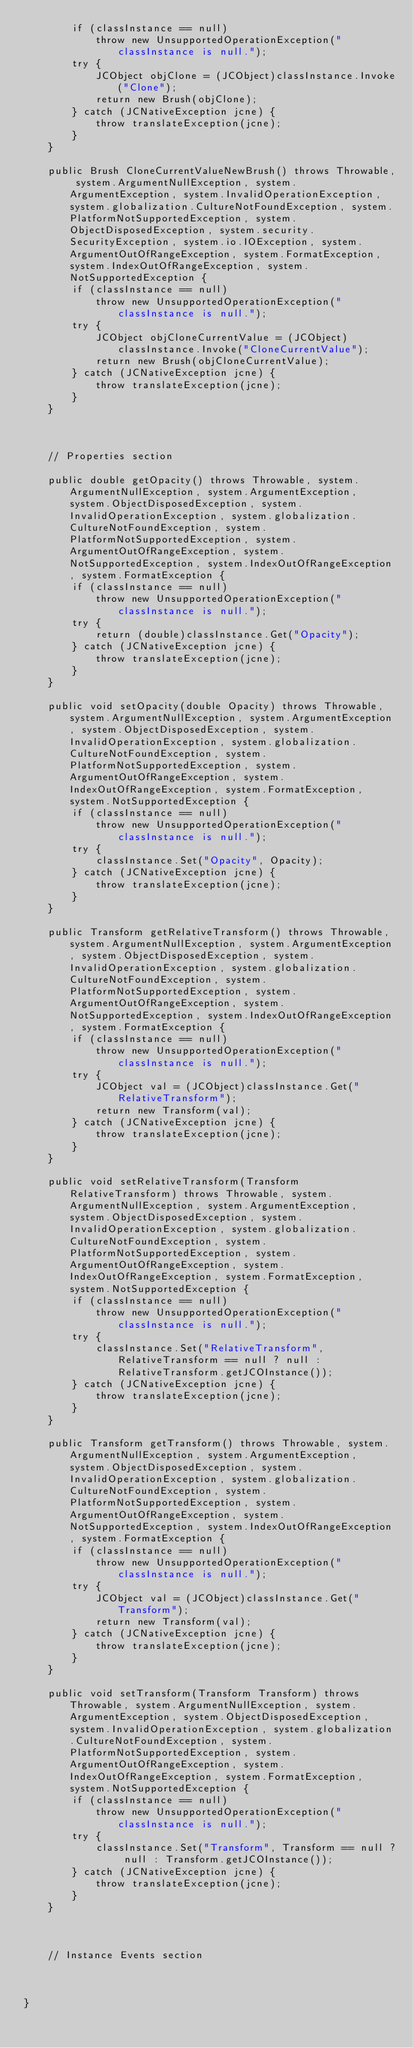<code> <loc_0><loc_0><loc_500><loc_500><_Java_>        if (classInstance == null)
            throw new UnsupportedOperationException("classInstance is null.");
        try {
            JCObject objClone = (JCObject)classInstance.Invoke("Clone");
            return new Brush(objClone);
        } catch (JCNativeException jcne) {
            throw translateException(jcne);
        }
    }

    public Brush CloneCurrentValueNewBrush() throws Throwable, system.ArgumentNullException, system.ArgumentException, system.InvalidOperationException, system.globalization.CultureNotFoundException, system.PlatformNotSupportedException, system.ObjectDisposedException, system.security.SecurityException, system.io.IOException, system.ArgumentOutOfRangeException, system.FormatException, system.IndexOutOfRangeException, system.NotSupportedException {
        if (classInstance == null)
            throw new UnsupportedOperationException("classInstance is null.");
        try {
            JCObject objCloneCurrentValue = (JCObject)classInstance.Invoke("CloneCurrentValue");
            return new Brush(objCloneCurrentValue);
        } catch (JCNativeException jcne) {
            throw translateException(jcne);
        }
    }


    
    // Properties section
    
    public double getOpacity() throws Throwable, system.ArgumentNullException, system.ArgumentException, system.ObjectDisposedException, system.InvalidOperationException, system.globalization.CultureNotFoundException, system.PlatformNotSupportedException, system.ArgumentOutOfRangeException, system.NotSupportedException, system.IndexOutOfRangeException, system.FormatException {
        if (classInstance == null)
            throw new UnsupportedOperationException("classInstance is null.");
        try {
            return (double)classInstance.Get("Opacity");
        } catch (JCNativeException jcne) {
            throw translateException(jcne);
        }
    }

    public void setOpacity(double Opacity) throws Throwable, system.ArgumentNullException, system.ArgumentException, system.ObjectDisposedException, system.InvalidOperationException, system.globalization.CultureNotFoundException, system.PlatformNotSupportedException, system.ArgumentOutOfRangeException, system.IndexOutOfRangeException, system.FormatException, system.NotSupportedException {
        if (classInstance == null)
            throw new UnsupportedOperationException("classInstance is null.");
        try {
            classInstance.Set("Opacity", Opacity);
        } catch (JCNativeException jcne) {
            throw translateException(jcne);
        }
    }

    public Transform getRelativeTransform() throws Throwable, system.ArgumentNullException, system.ArgumentException, system.ObjectDisposedException, system.InvalidOperationException, system.globalization.CultureNotFoundException, system.PlatformNotSupportedException, system.ArgumentOutOfRangeException, system.NotSupportedException, system.IndexOutOfRangeException, system.FormatException {
        if (classInstance == null)
            throw new UnsupportedOperationException("classInstance is null.");
        try {
            JCObject val = (JCObject)classInstance.Get("RelativeTransform");
            return new Transform(val);
        } catch (JCNativeException jcne) {
            throw translateException(jcne);
        }
    }

    public void setRelativeTransform(Transform RelativeTransform) throws Throwable, system.ArgumentNullException, system.ArgumentException, system.ObjectDisposedException, system.InvalidOperationException, system.globalization.CultureNotFoundException, system.PlatformNotSupportedException, system.ArgumentOutOfRangeException, system.IndexOutOfRangeException, system.FormatException, system.NotSupportedException {
        if (classInstance == null)
            throw new UnsupportedOperationException("classInstance is null.");
        try {
            classInstance.Set("RelativeTransform", RelativeTransform == null ? null : RelativeTransform.getJCOInstance());
        } catch (JCNativeException jcne) {
            throw translateException(jcne);
        }
    }

    public Transform getTransform() throws Throwable, system.ArgumentNullException, system.ArgumentException, system.ObjectDisposedException, system.InvalidOperationException, system.globalization.CultureNotFoundException, system.PlatformNotSupportedException, system.ArgumentOutOfRangeException, system.NotSupportedException, system.IndexOutOfRangeException, system.FormatException {
        if (classInstance == null)
            throw new UnsupportedOperationException("classInstance is null.");
        try {
            JCObject val = (JCObject)classInstance.Get("Transform");
            return new Transform(val);
        } catch (JCNativeException jcne) {
            throw translateException(jcne);
        }
    }

    public void setTransform(Transform Transform) throws Throwable, system.ArgumentNullException, system.ArgumentException, system.ObjectDisposedException, system.InvalidOperationException, system.globalization.CultureNotFoundException, system.PlatformNotSupportedException, system.ArgumentOutOfRangeException, system.IndexOutOfRangeException, system.FormatException, system.NotSupportedException {
        if (classInstance == null)
            throw new UnsupportedOperationException("classInstance is null.");
        try {
            classInstance.Set("Transform", Transform == null ? null : Transform.getJCOInstance());
        } catch (JCNativeException jcne) {
            throw translateException(jcne);
        }
    }



    // Instance Events section
    


}</code> 